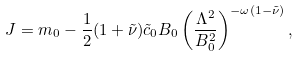Convert formula to latex. <formula><loc_0><loc_0><loc_500><loc_500>J = m _ { 0 } - \frac { 1 } { 2 } ( 1 + \tilde { \nu } ) \tilde { c } _ { 0 } B _ { 0 } \left ( \frac { \Lambda ^ { 2 } } { B _ { 0 } ^ { 2 } } \right ) ^ { - \omega ( 1 - \tilde { \nu } ) } ,</formula> 